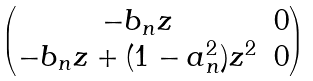<formula> <loc_0><loc_0><loc_500><loc_500>\begin{pmatrix} - b _ { n } z & 0 \\ - b _ { n } z + ( 1 - a _ { n } ^ { 2 } ) z ^ { 2 } & 0 \end{pmatrix}</formula> 